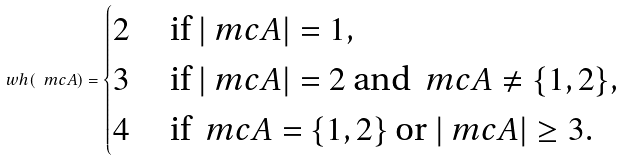<formula> <loc_0><loc_0><loc_500><loc_500>\ w h ( \ m c { A } ) = \begin{cases} 2 \quad \text { if } | \ m c { A } | = 1 , \\ 3 \quad \text { if } | \ m c { A } | = 2 \text { and } \ m c { A } \neq \{ 1 , 2 \} , \\ 4 \quad \text { if } \ m c { A } = \{ 1 , 2 \} \text { or } | \ m c { A } | \geq 3 . \end{cases}</formula> 